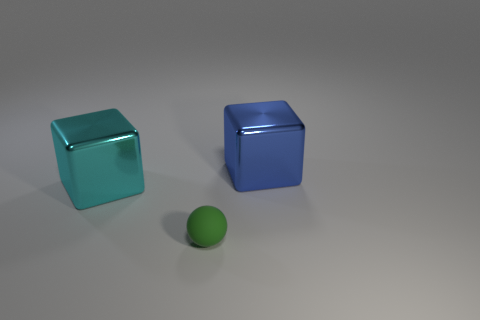Is the number of big cyan things less than the number of large purple things?
Your response must be concise. No. Are there any other cyan metal blocks that have the same size as the cyan metal cube?
Your answer should be very brief. No. Do the blue shiny thing and the metallic object left of the blue shiny object have the same shape?
Provide a short and direct response. Yes. What number of balls are big metallic things or small green rubber objects?
Provide a short and direct response. 1. The small matte thing is what color?
Provide a succinct answer. Green. Is the number of big yellow rubber cubes greater than the number of metal objects?
Offer a terse response. No. How many objects are big blocks that are on the right side of the small matte ball or tiny green metal cubes?
Your answer should be very brief. 1. Is the material of the tiny object the same as the blue block?
Make the answer very short. No. There is a cyan object that is the same shape as the blue thing; what size is it?
Offer a terse response. Large. There is a metallic thing that is right of the green matte thing; is its shape the same as the thing that is in front of the cyan shiny thing?
Provide a succinct answer. No. 